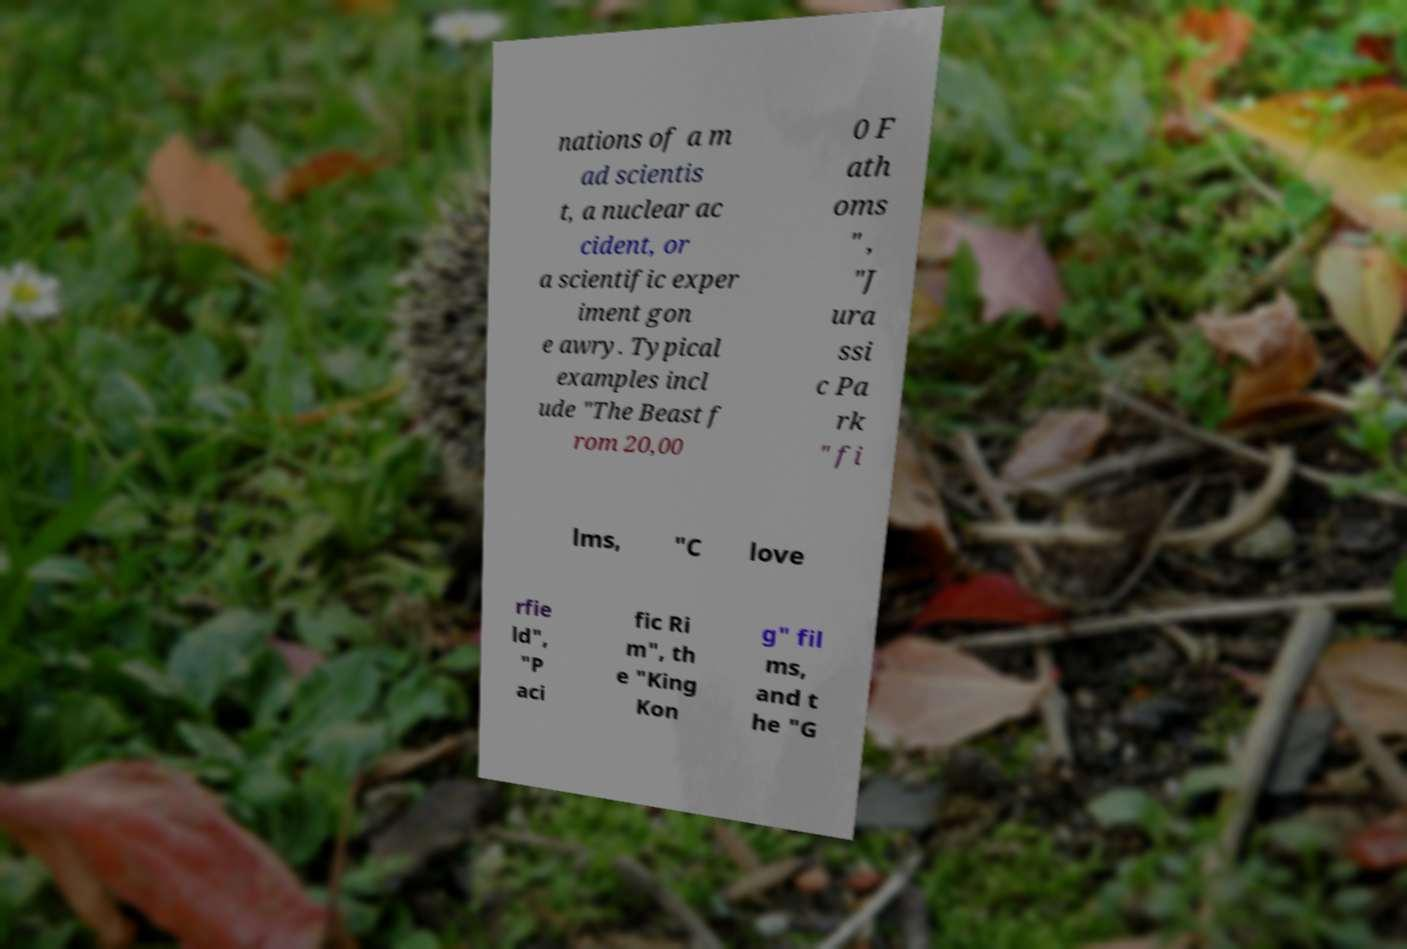Can you accurately transcribe the text from the provided image for me? nations of a m ad scientis t, a nuclear ac cident, or a scientific exper iment gon e awry. Typical examples incl ude "The Beast f rom 20,00 0 F ath oms " , "J ura ssi c Pa rk " fi lms, "C love rfie ld", "P aci fic Ri m", th e "King Kon g" fil ms, and t he "G 